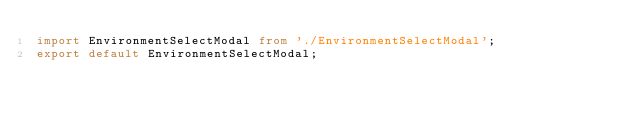<code> <loc_0><loc_0><loc_500><loc_500><_TypeScript_>import EnvironmentSelectModal from './EnvironmentSelectModal';
export default EnvironmentSelectModal;
</code> 